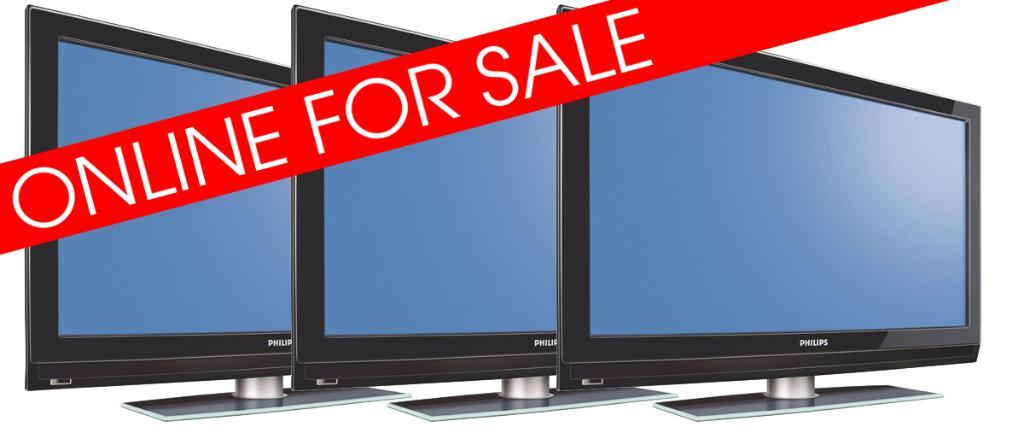<image>
Describe the image concisely. Three Philips televisions are lined up with a red banner across them stating they are online for sale. 